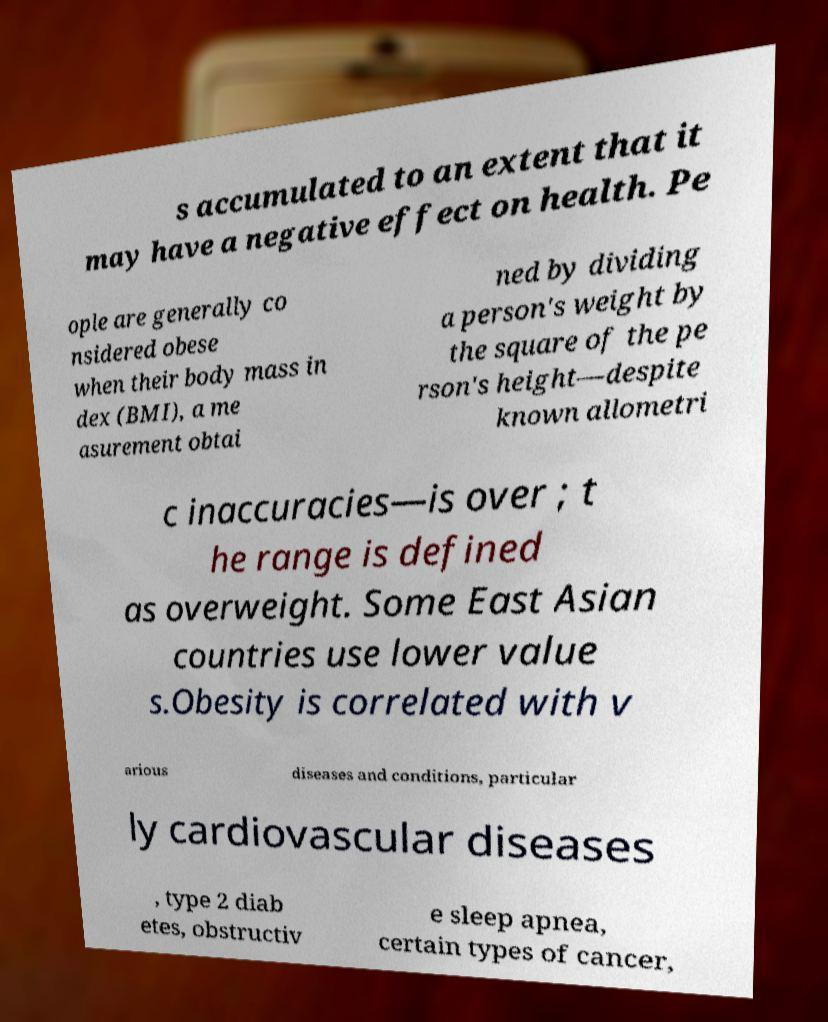Please identify and transcribe the text found in this image. s accumulated to an extent that it may have a negative effect on health. Pe ople are generally co nsidered obese when their body mass in dex (BMI), a me asurement obtai ned by dividing a person's weight by the square of the pe rson's height—despite known allometri c inaccuracies—is over ; t he range is defined as overweight. Some East Asian countries use lower value s.Obesity is correlated with v arious diseases and conditions, particular ly cardiovascular diseases , type 2 diab etes, obstructiv e sleep apnea, certain types of cancer, 